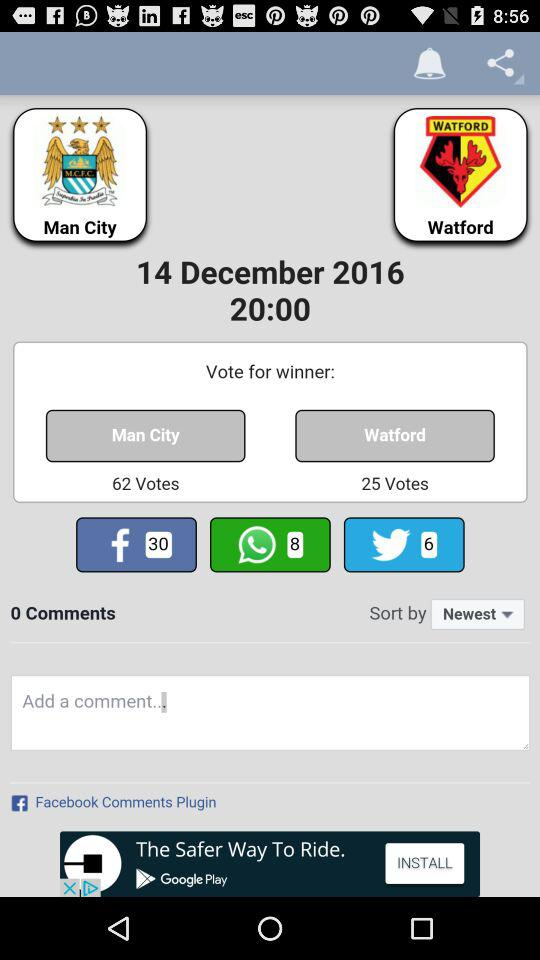What is the number of votes for "Watford"? The number of votes for "Watford" is 25. 